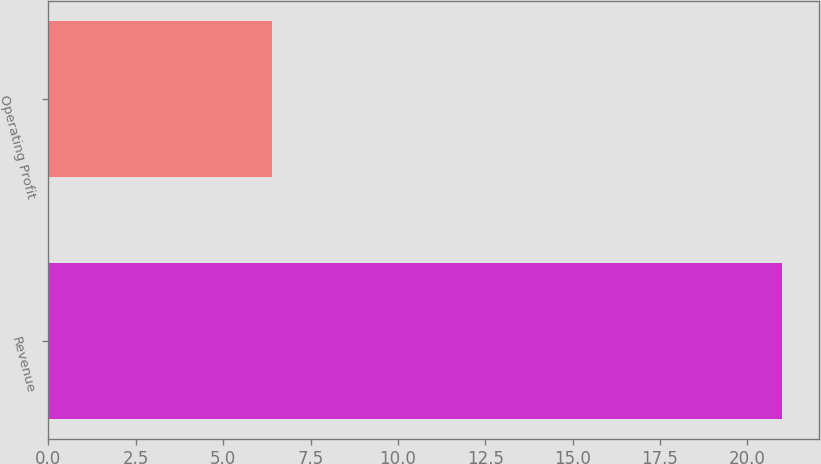Convert chart to OTSL. <chart><loc_0><loc_0><loc_500><loc_500><bar_chart><fcel>Revenue<fcel>Operating Profit<nl><fcel>21<fcel>6.4<nl></chart> 